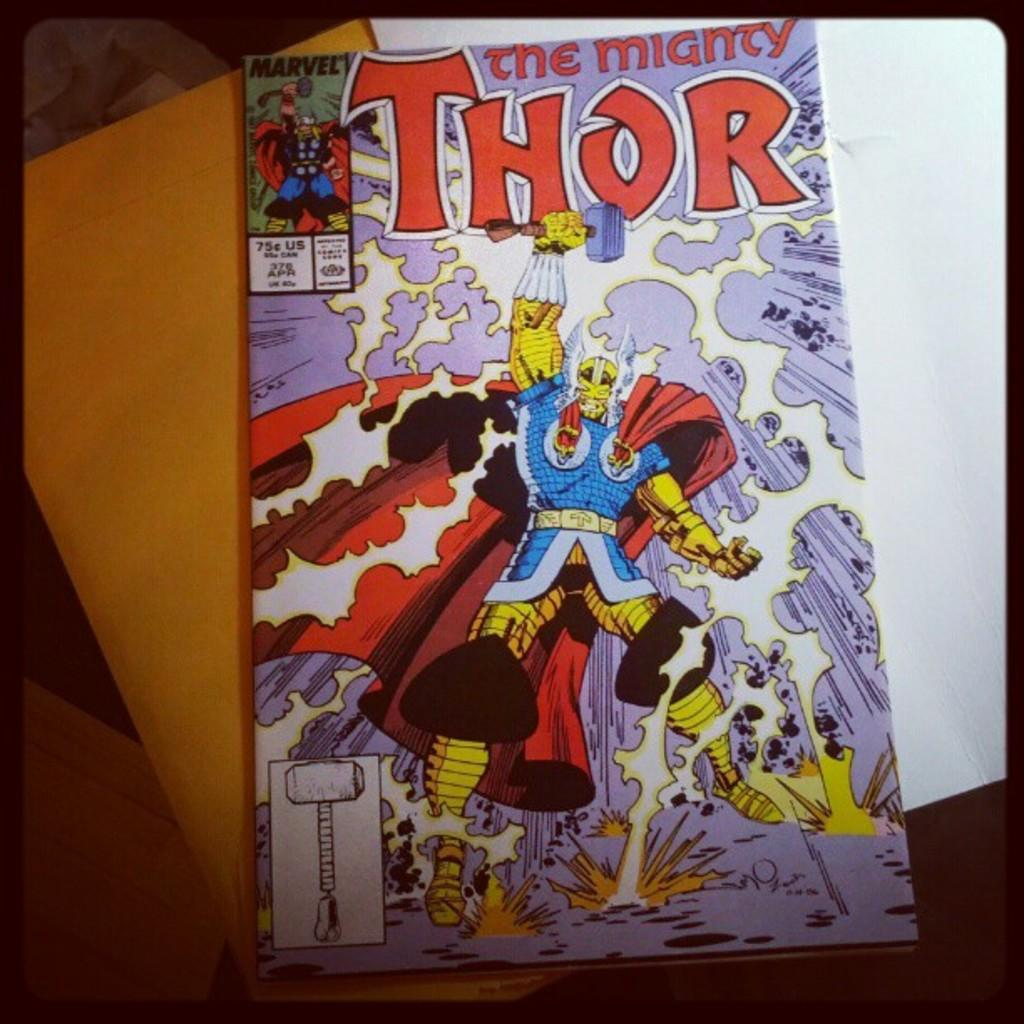Provide a one-sentence caption for the provided image. A "THOR the mighty" comic book with an illustration of Thor and his hammer upon the cover sits atop a manila envelope. 